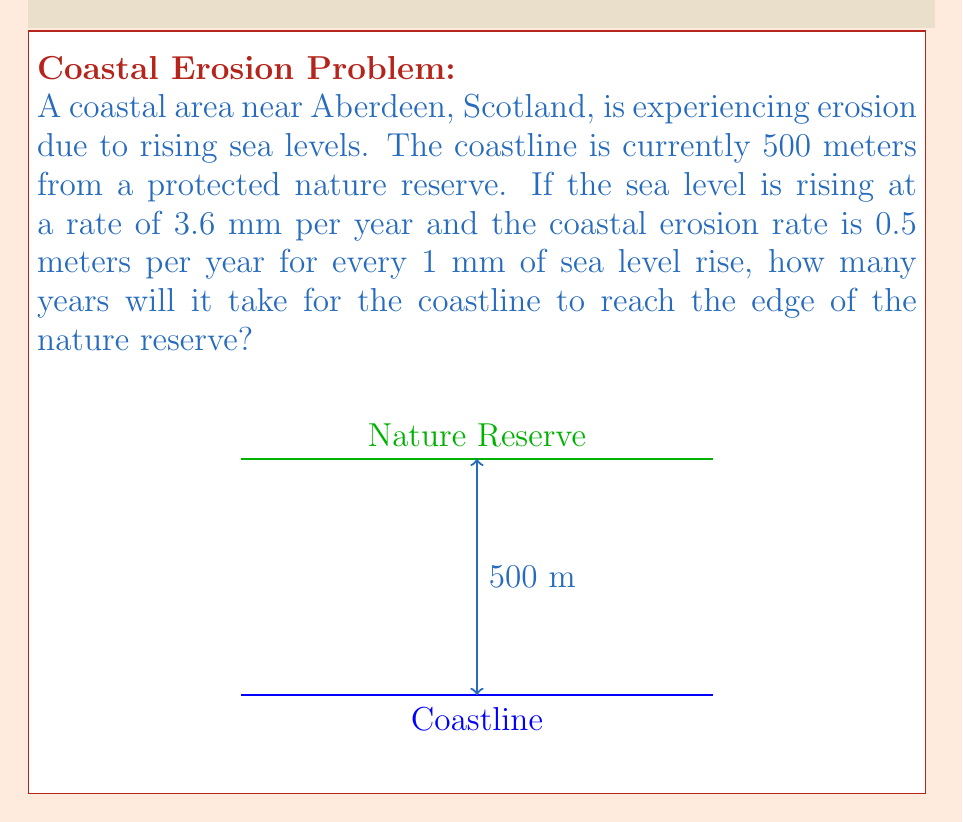Teach me how to tackle this problem. Let's approach this problem step-by-step:

1) First, we need to calculate the coastal erosion rate per year:
   Sea level rise per year = 3.6 mm
   Erosion rate = 0.5 m per 1 mm of sea level rise
   
   Annual erosion rate = $3.6 \times 0.5 = 1.8$ meters per year

2) Now, we need to determine how long it will take for 500 meters of coastline to erode:

   Let $t$ be the time in years.
   
   Distance eroded = Rate × Time
   
   $$500 = 1.8t$$

3) Solving for $t$:

   $$t = \frac{500}{1.8} \approx 277.78$$

4) Since we can't have a fractional year in this context, we round up to the nearest whole year.

Therefore, it will take 278 years for the coastline to reach the edge of the nature reserve.
Answer: 278 years 